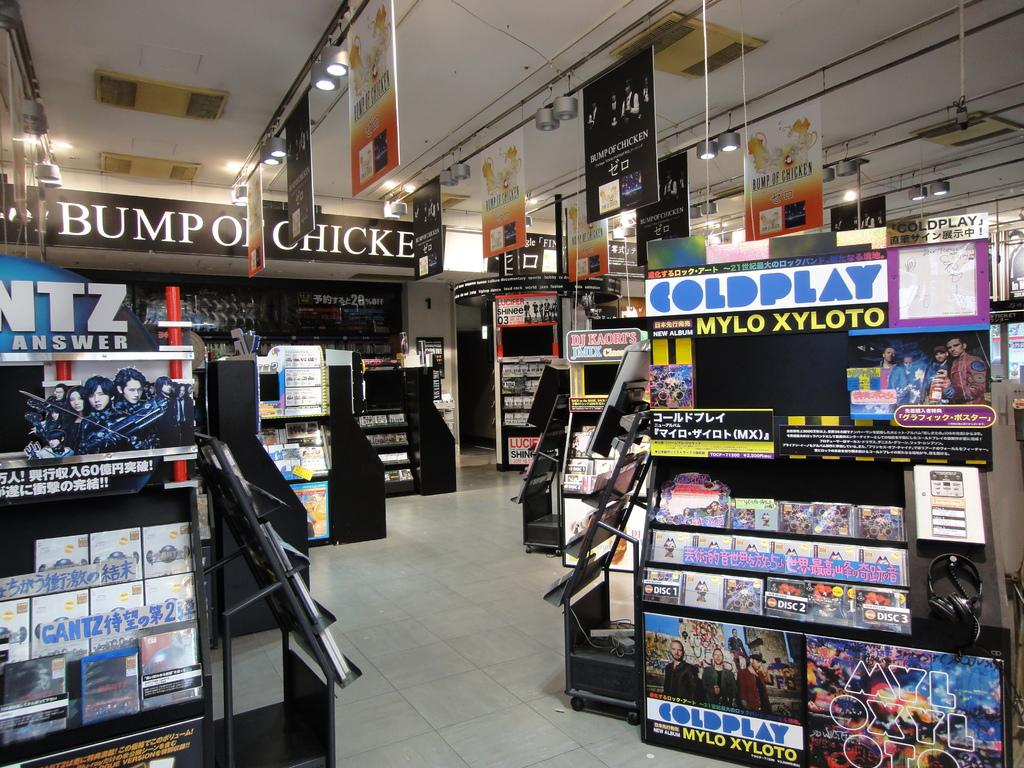<image>
Summarize the visual content of the image. Coldplay display at a Japanese electronics retail store. 